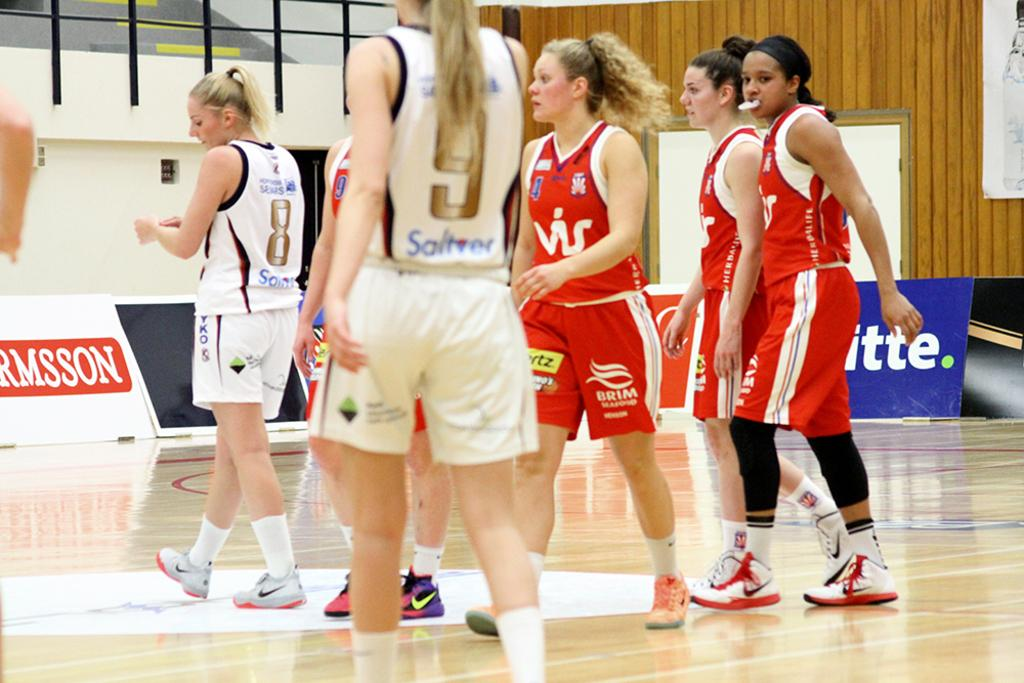<image>
Provide a brief description of the given image. Women basketball players in red jerseys with VIS on their shirts 